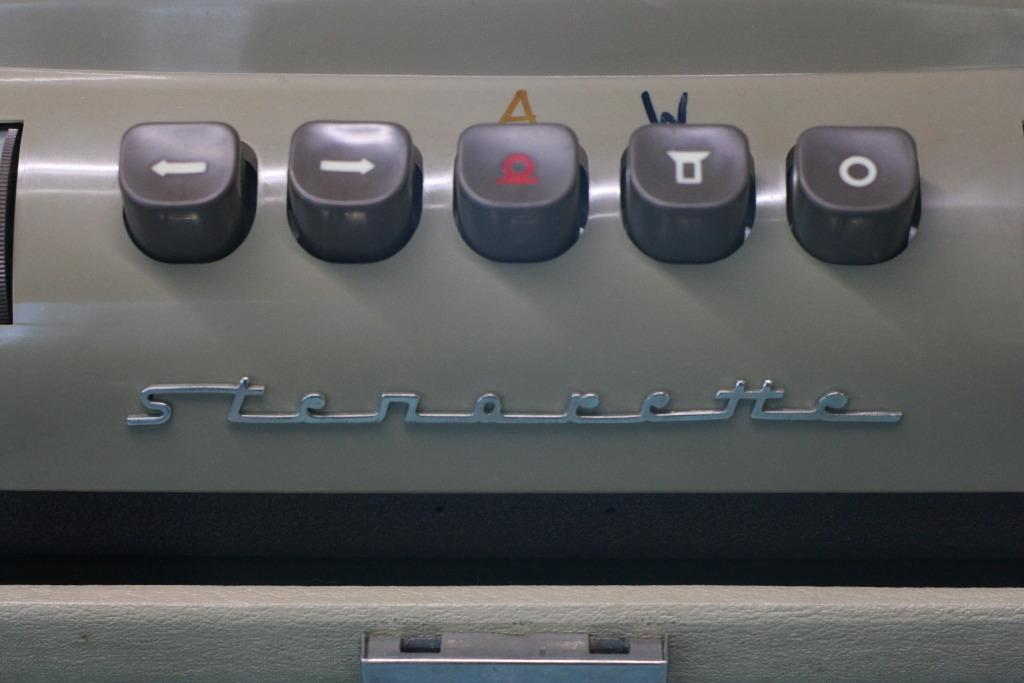Provide a one-sentence caption for the provided image. Below the buttons is the brand of Stenorette. 